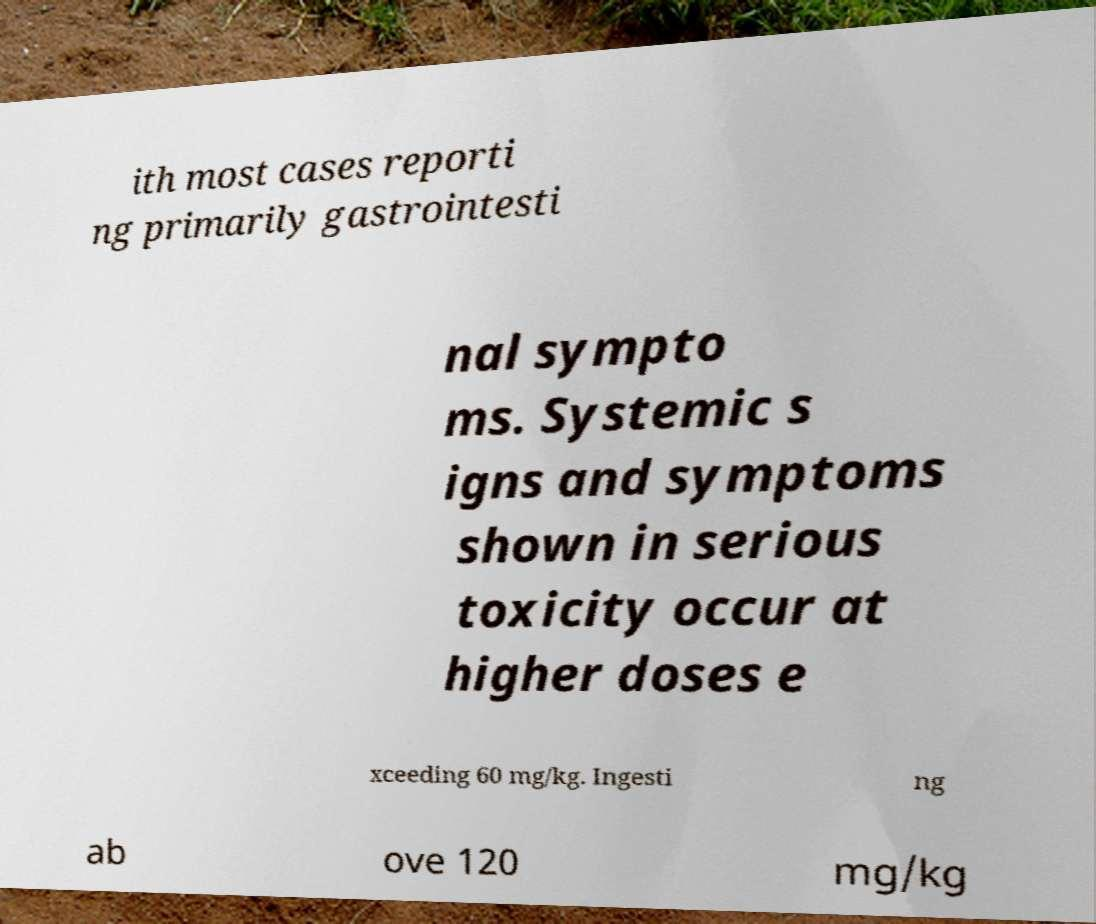Can you accurately transcribe the text from the provided image for me? ith most cases reporti ng primarily gastrointesti nal sympto ms. Systemic s igns and symptoms shown in serious toxicity occur at higher doses e xceeding 60 mg/kg. Ingesti ng ab ove 120 mg/kg 